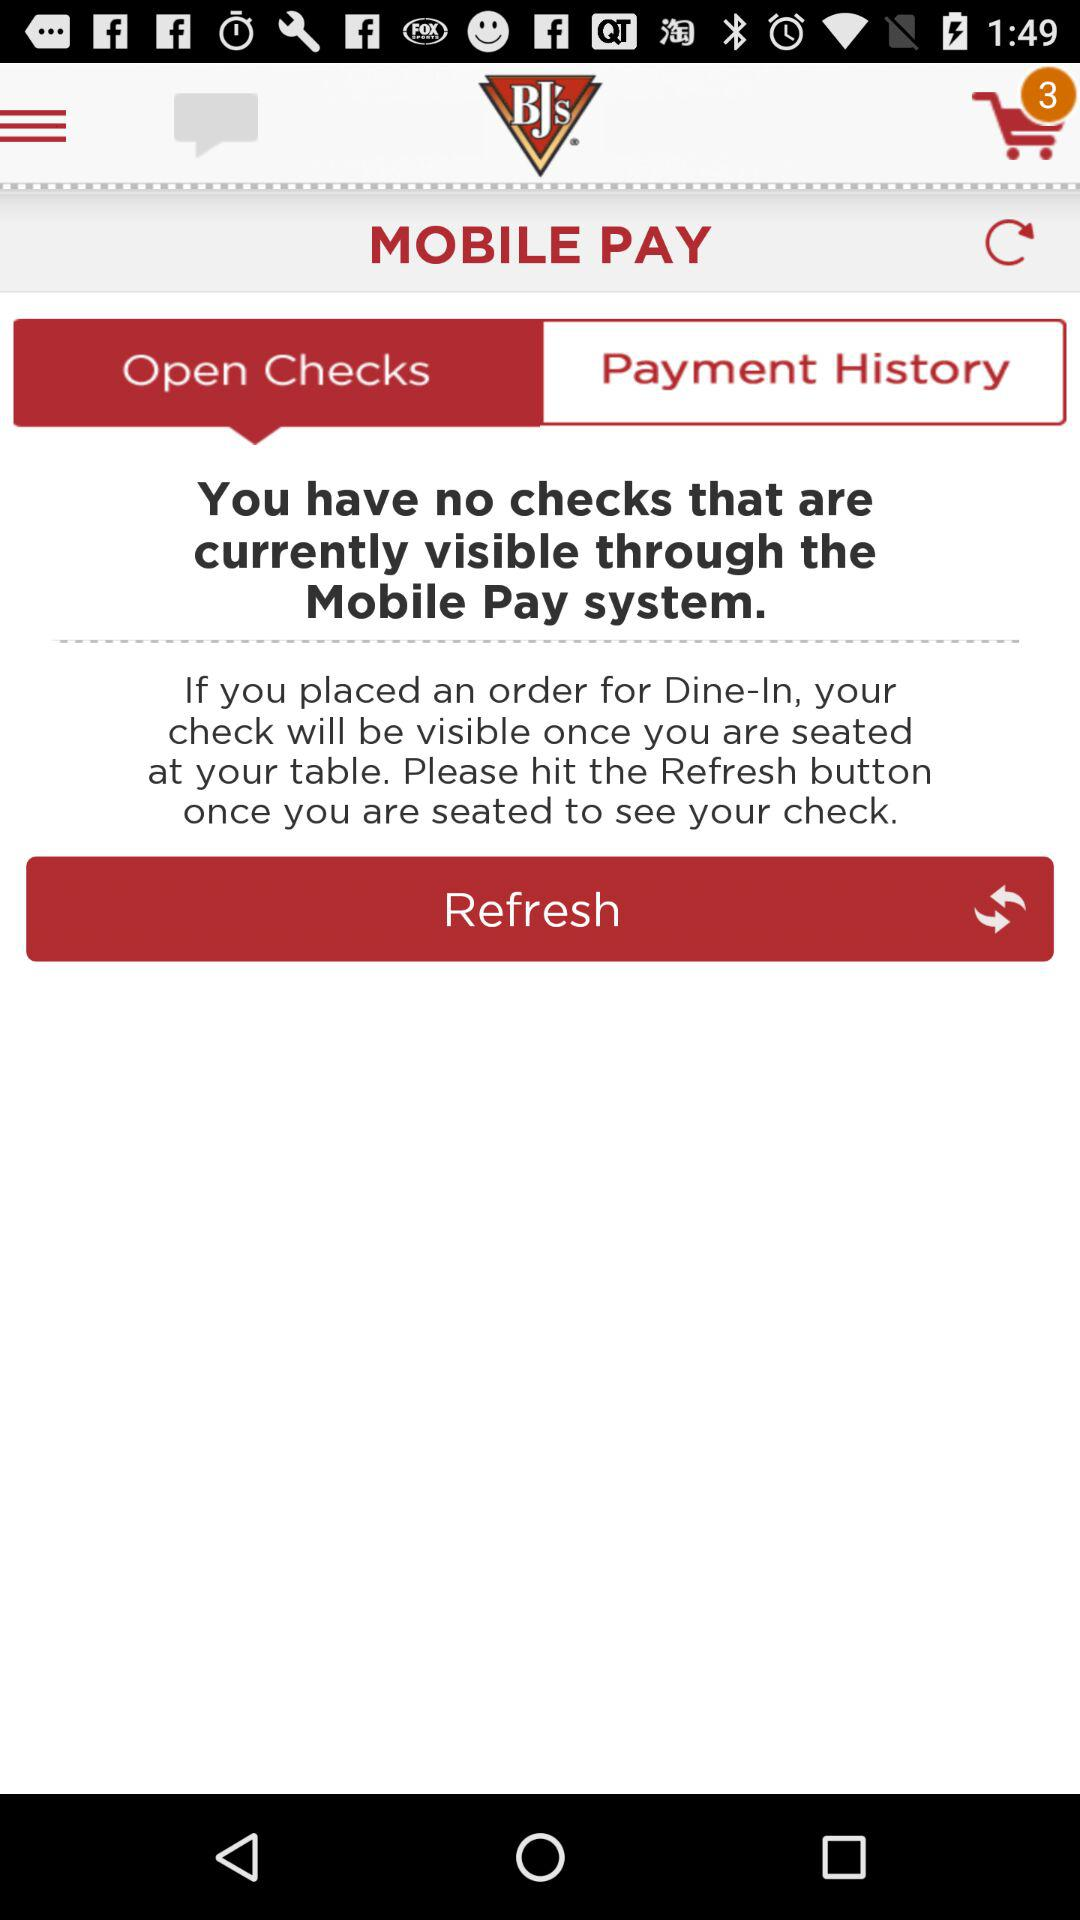How many items are in the cart? There are 3 items in the cart. 